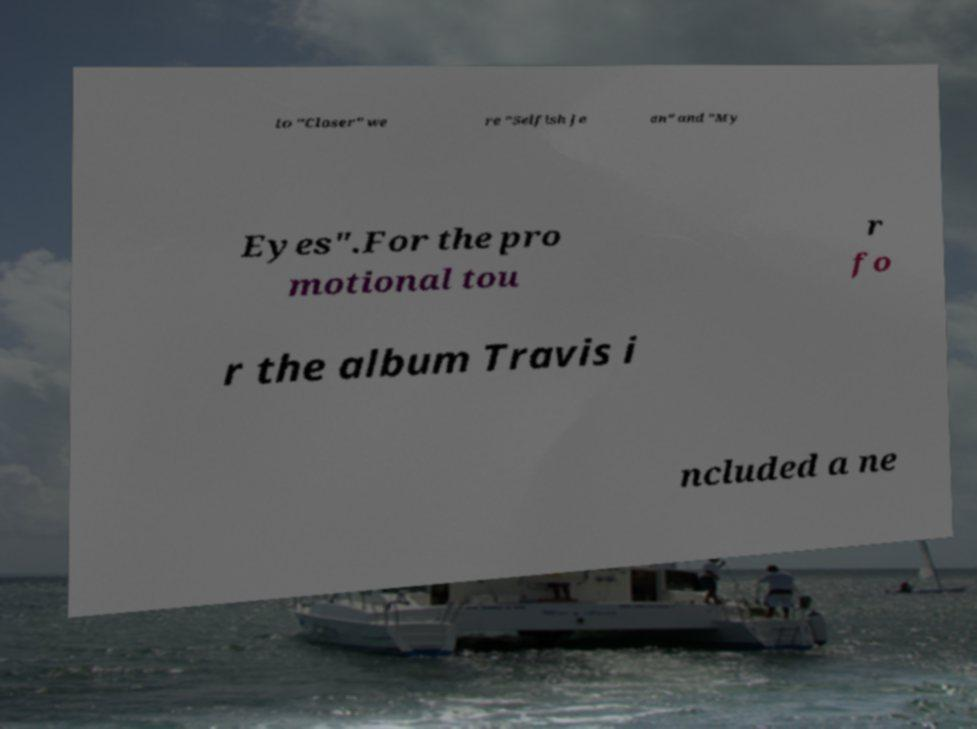Could you extract and type out the text from this image? to "Closer" we re "Selfish Je an" and "My Eyes".For the pro motional tou r fo r the album Travis i ncluded a ne 